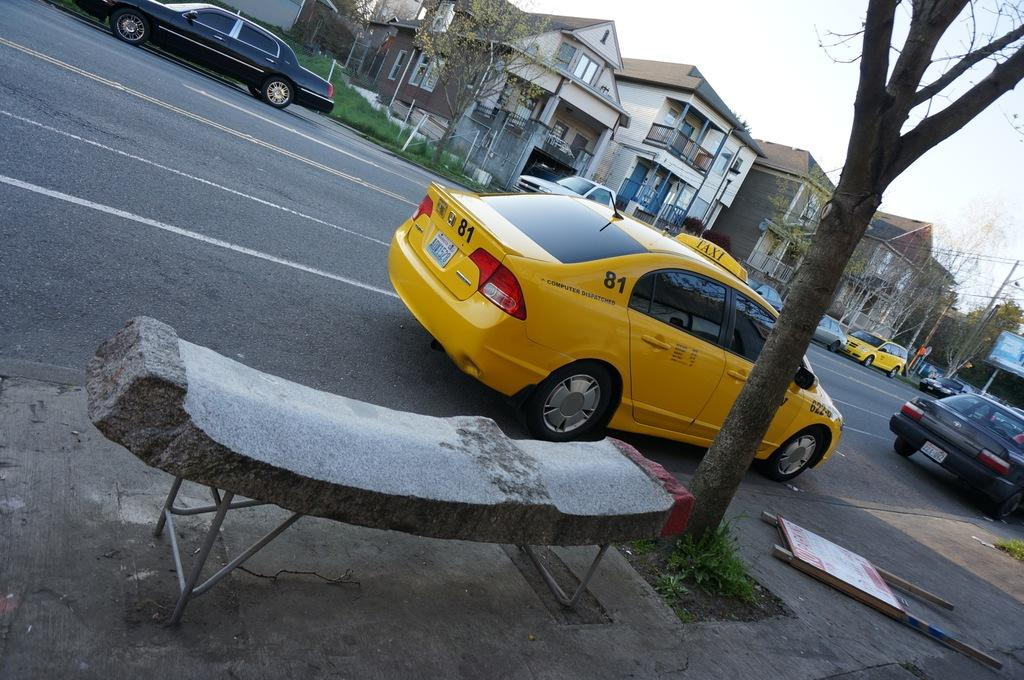<image>
Write a terse but informative summary of the picture. A yellow Taxi Honda car with the number 81 behind the car on a street. 